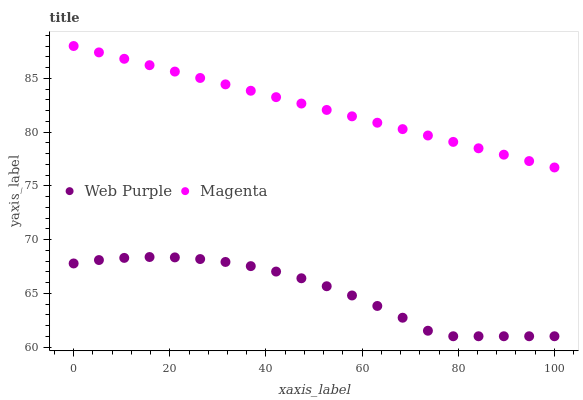Does Web Purple have the minimum area under the curve?
Answer yes or no. Yes. Does Magenta have the maximum area under the curve?
Answer yes or no. Yes. Does Magenta have the minimum area under the curve?
Answer yes or no. No. Is Magenta the smoothest?
Answer yes or no. Yes. Is Web Purple the roughest?
Answer yes or no. Yes. Is Magenta the roughest?
Answer yes or no. No. Does Web Purple have the lowest value?
Answer yes or no. Yes. Does Magenta have the lowest value?
Answer yes or no. No. Does Magenta have the highest value?
Answer yes or no. Yes. Is Web Purple less than Magenta?
Answer yes or no. Yes. Is Magenta greater than Web Purple?
Answer yes or no. Yes. Does Web Purple intersect Magenta?
Answer yes or no. No. 